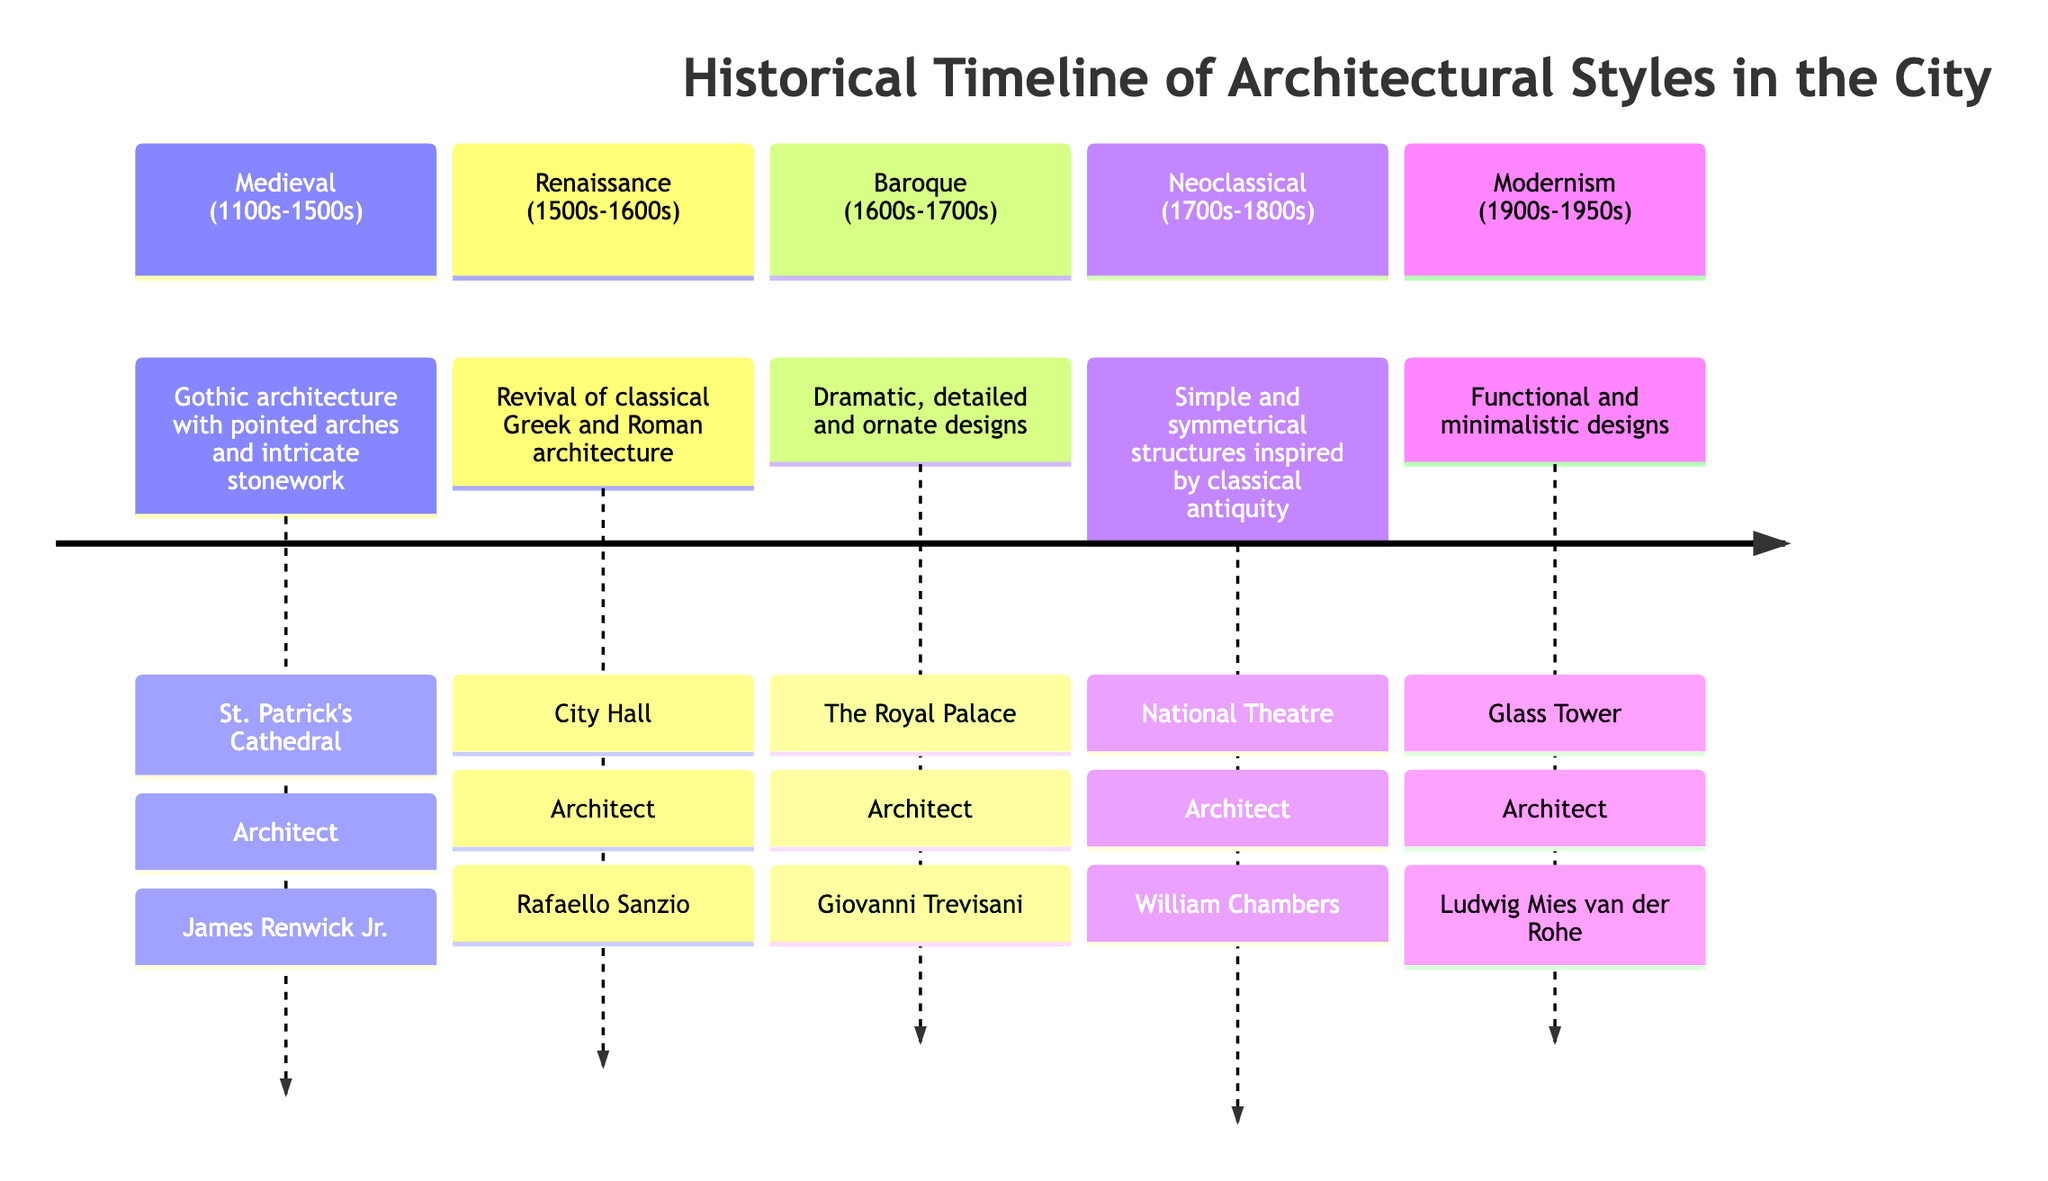What architectural style is featured in St. Patrick's Cathedral? The diagram indicates that St. Patrick's Cathedral is built in the Gothic architectural style. This is evident in the section labeled "Medieval (1100s-1500s)" where Gothic architecture is described along with the corresponding building.
Answer: Gothic Who is the architect of the National Theatre? The diagram specifies that the National Theatre was designed by William Chambers, as stated in the section covering Neoclassical architecture, which includes this building's details.
Answer: William Chambers How many architectural styles are represented in the timeline? The diagram shows five distinct sections, each representing a different architectural style, namely Medieval, Renaissance, Baroque, Neoclassical, and Modernism.
Answer: 5 Which architectural style comes after the Renaissance? Referring to the timeline in the diagram, the section immediately following Renaissance shows that Baroque architecture comes next, highlighting the order of styles presented.
Answer: Baroque What is the main characteristic of Modernism architecture according to the diagram? The diagram describes Modernism architecture as "Functional and minimalistic designs," which serves as the defining feature of this style, noted in the corresponding section on the timeline.
Answer: Functional and minimalistic designs Which building is associated with Giovanni Trevisani? Within the Baroque section of the diagram, The Royal Palace is clearly stated as the building associated with architect Giovanni Trevisani, highlighting his contribution to that architectural style.
Answer: The Royal Palace What time period corresponds to the Neoclassical architectural style? Looking at the diagram, the Neoclassical section is defined as occurring from the 1700s to the 1800s, explaining the specific timeframe for this style in the historical timeline.
Answer: 1700s-1800s How do the architectural styles transition in the timeline? The diagram shows a chronological transition from Medieval to Renaissance, then to Baroque, followed by Neoclassical, and finally Modernism. This sequence illustrates the evolution of architectural styles over time within the city.
Answer: Sequentially from Medieval to Modernism 